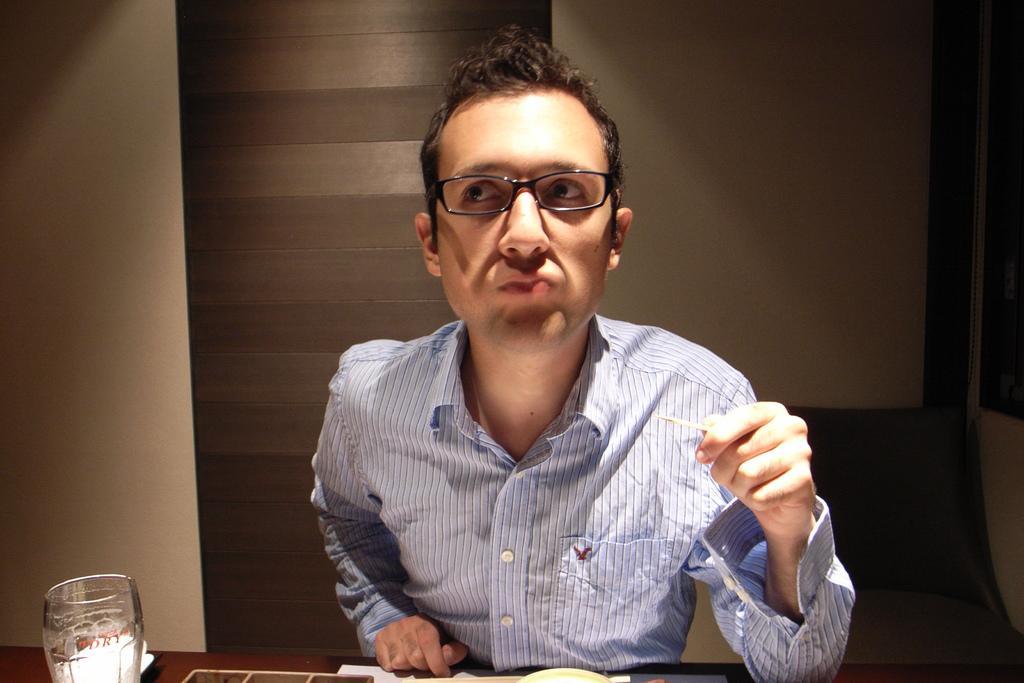Describe this image in one or two sentences. In this image we can see a man sitting, before him there is a table and we can see a glass placed on the table. In the background there is a wall. 